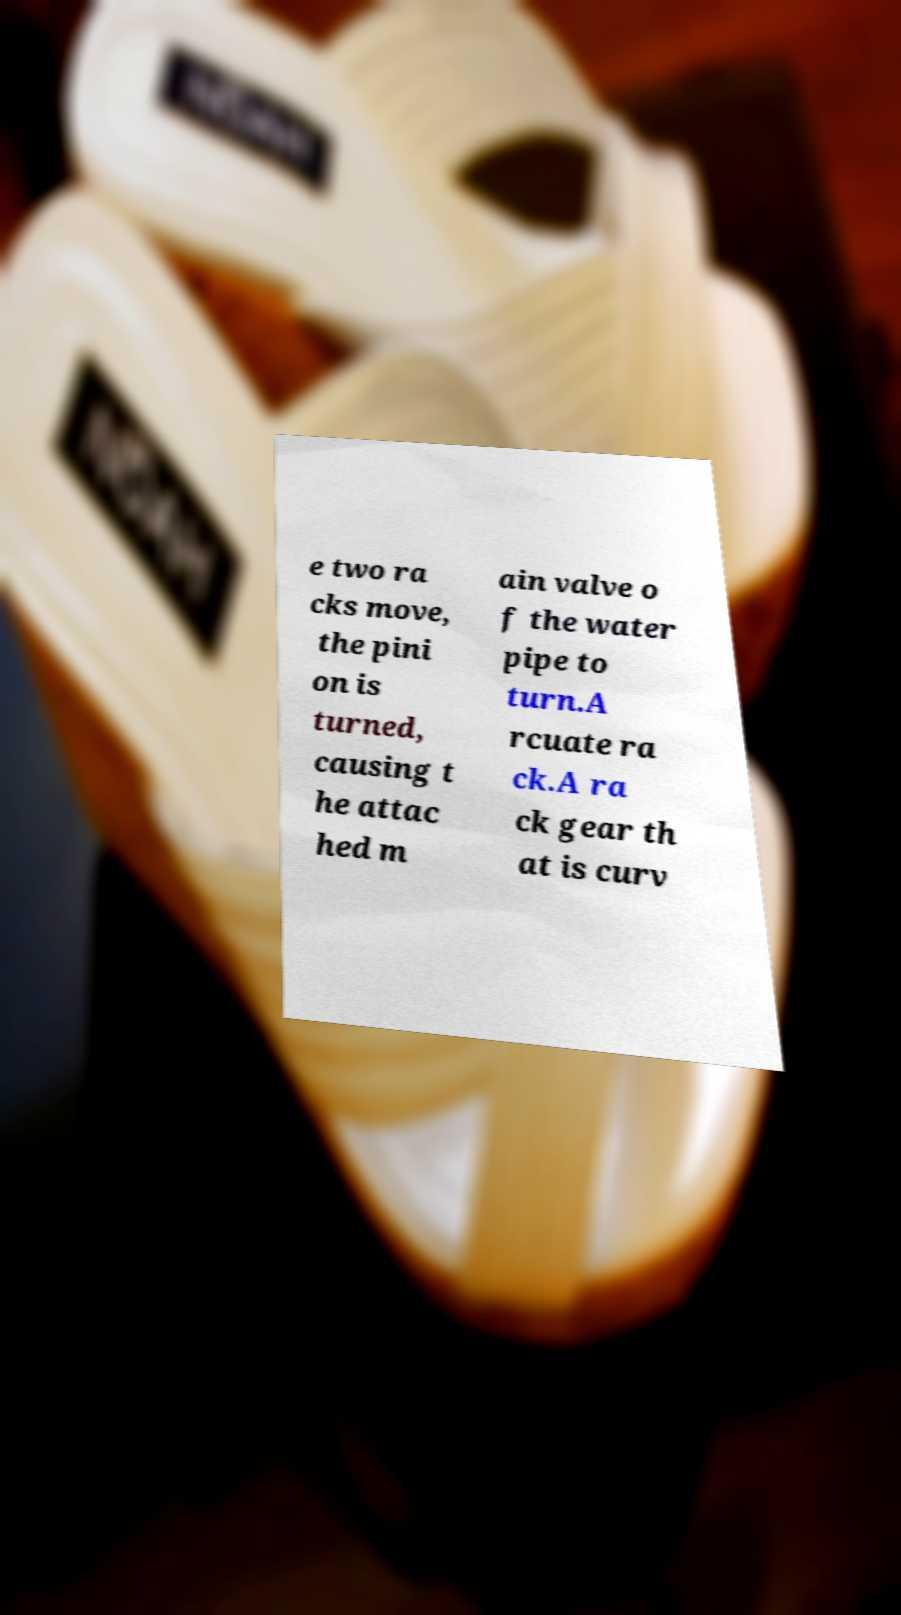Could you assist in decoding the text presented in this image and type it out clearly? e two ra cks move, the pini on is turned, causing t he attac hed m ain valve o f the water pipe to turn.A rcuate ra ck.A ra ck gear th at is curv 